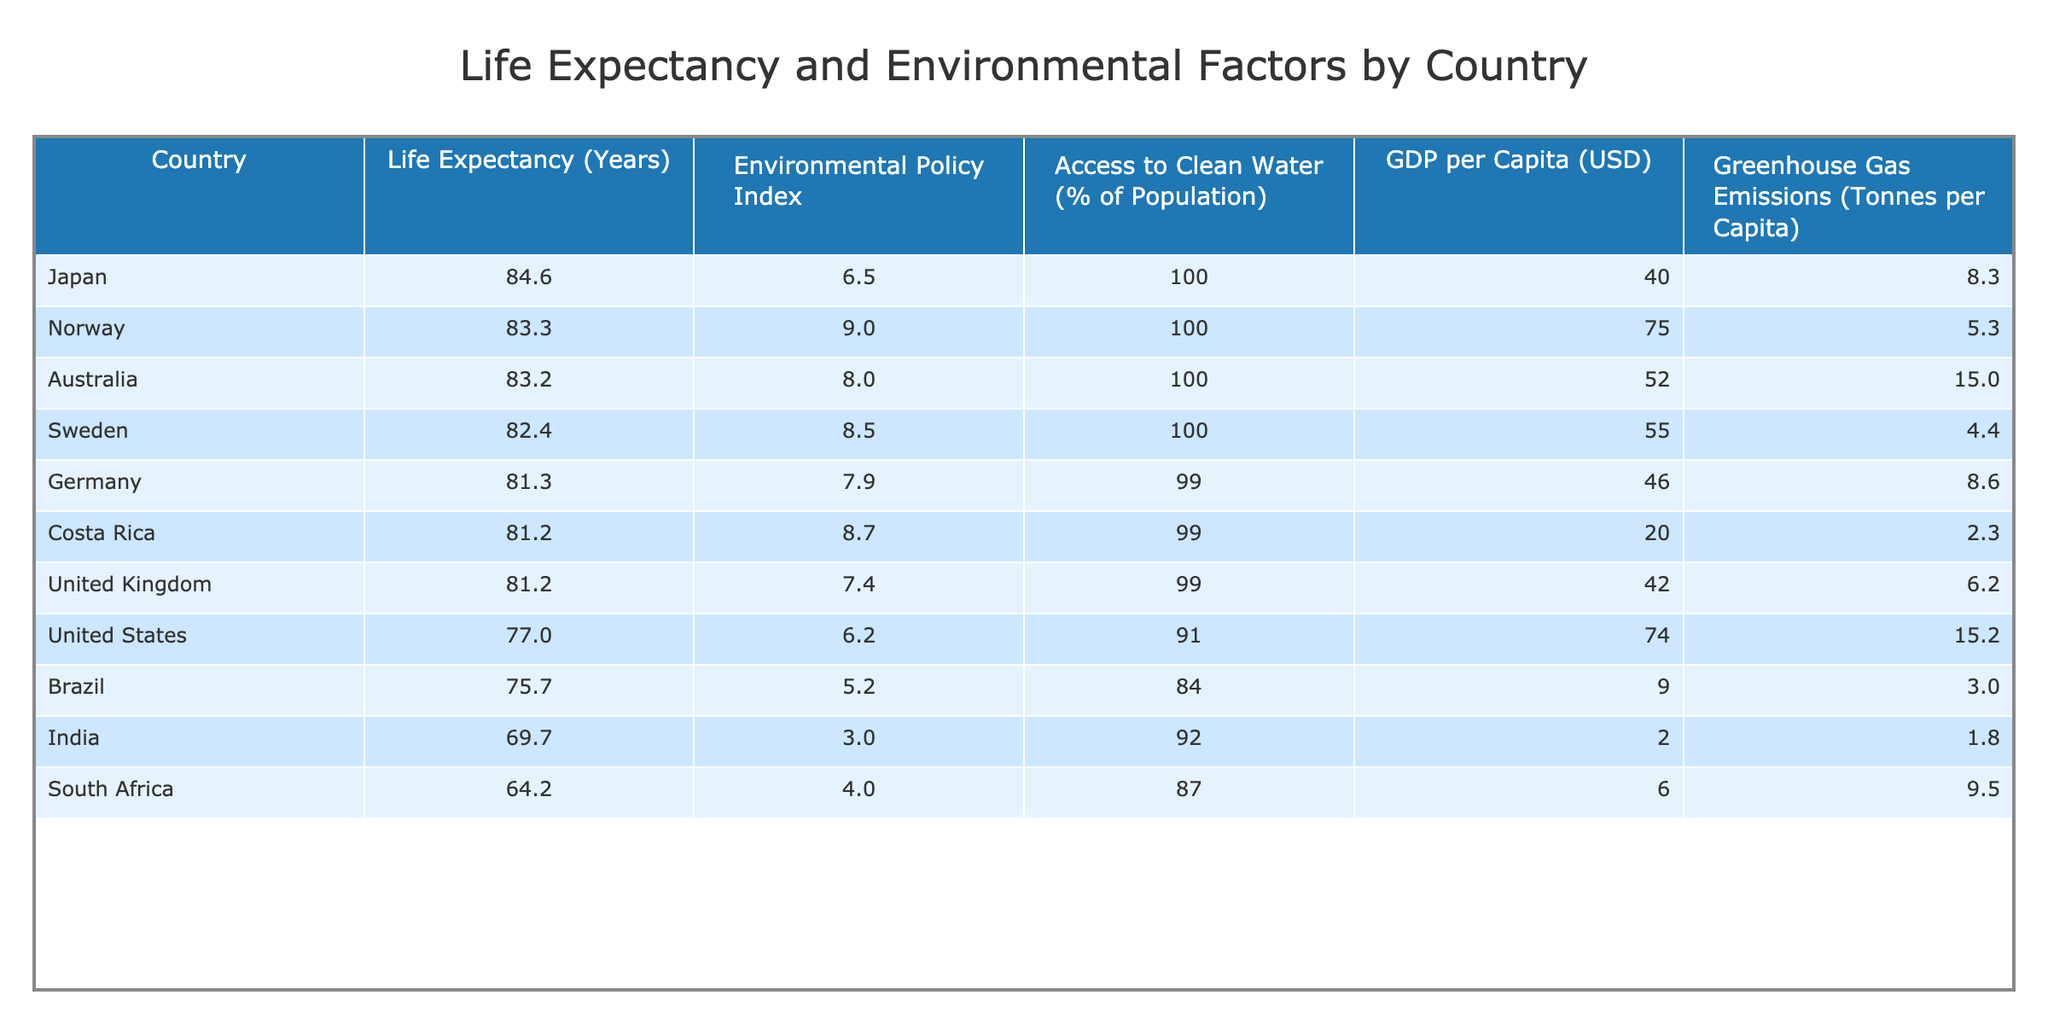What is the life expectancy of Japan? The table indicates Japan's life expectancy as listed under the "Life Expectancy (Years)" column, which shows Japan having a life expectancy of 84.6 years.
Answer: 84.6 years Which country has the highest Environmental Policy Index? By inspecting the "Environmental Policy Index" column, we find that Norway has the highest value at 9.0, making it the leader in this category.
Answer: Norway What is the average life expectancy of countries with an Environmental Policy Index above 8? The countries with an Environmental Policy Index above 8 are Sweden, Costa Rica, Norway, and Australia. Their life expectancies are 82.4, 81.2, 83.3, and 83.2, respectively. Adding these gives 330.1 years. Dividing by 4 (the number of countries) gives an average of 82.525 years.
Answer: 82.525 years Does Germany have a higher life expectancy than South Africa? Comparing the life expectancy values in the table, Germany's is 81.3 years while South Africa's is 64.2 years. Since 81.3 is greater than 64.2, the statement is true.
Answer: Yes What is the difference in life expectancy between the country with the highest and lowest values in the table? Evaluating the highest life expectancy in the table, which is Japan at 84.6 years, and the lowest, which is India at 69.7 years, we calculate the difference: 84.6 - 69.7 = 14.9 years.
Answer: 14.9 years Which country has access to clean water percentage lower than 90%? Looking at the "Access to Clean Water (% of Population)" column, the only country with less than 90% is India, which has a percentage of 92%, thus the statement is false for all others which have 90% or higher.
Answer: No What is the total GDP per Capita for the countries with a life expectancy greater than 80 years? The countries with a life expectancy greater than 80 years are Sweden (55), Germany (46), Costa Rica (20), Japan (40), Norway (75), and Australia (52). Adding their GDP per Capita gives 55 + 46 + 20 + 40 + 75 + 52 = 288.
Answer: 288 Is the Environmental Policy Index of the United Kingdom higher than that of India? According to the "Environmental Policy Index" column, the United Kingdom has an index of 7.4 while India has 3.0. Since 7.4 is greater than 3.0, the statement is true.
Answer: Yes 